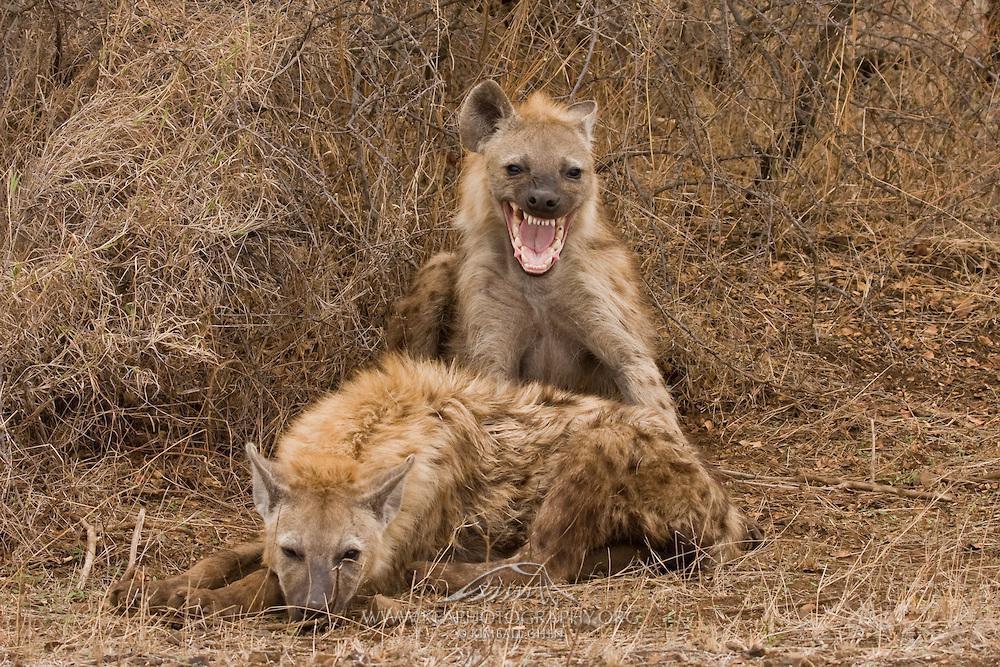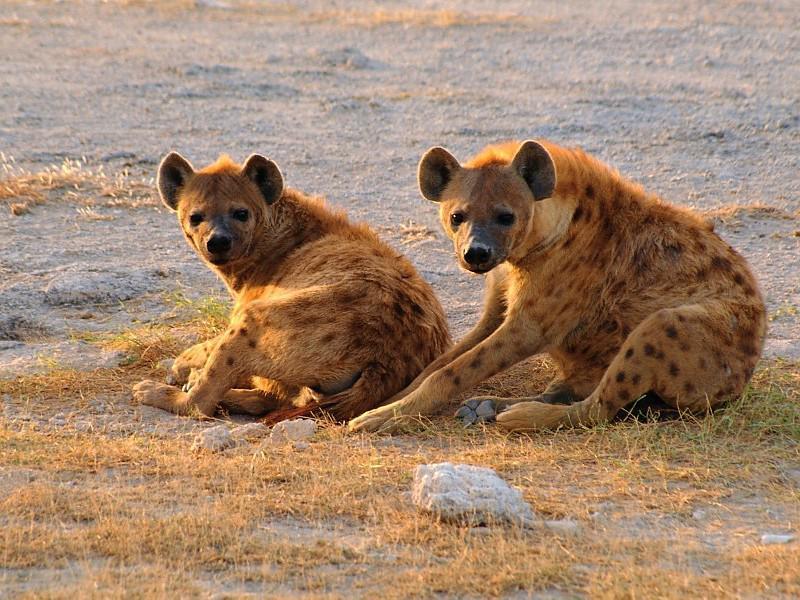The first image is the image on the left, the second image is the image on the right. For the images shown, is this caption "The left image contains at least two hyenas." true? Answer yes or no. Yes. The first image is the image on the left, the second image is the image on the right. Examine the images to the left and right. Is the description "The left image includes a fang-baring hyena with wide open mouth, and the right image contains exactly two hyenas in matching poses." accurate? Answer yes or no. Yes. 